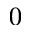<formula> <loc_0><loc_0><loc_500><loc_500>0</formula> 